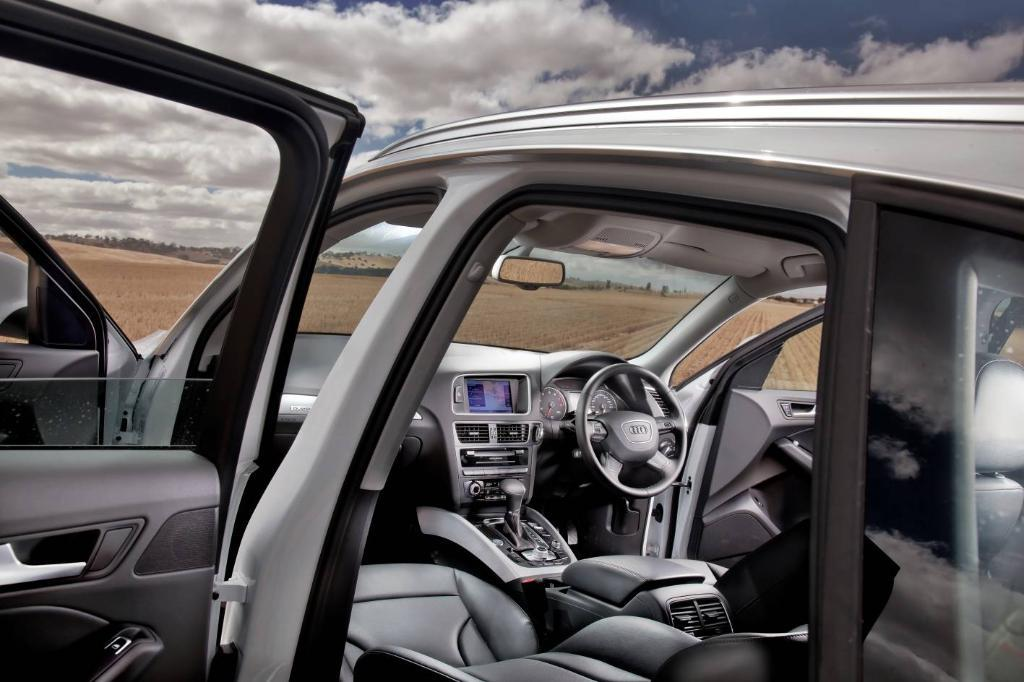What type of vehicle is in the image? The image contains a vehicle, but the specific type is not mentioned. What is located in front of the driver's seat in the vehicle? There is a steering wheel in the vehicle. What allows the driver to see the road ahead in the vehicle? There is a windshield in the vehicle. What helps the driver see behind the vehicle? There is a mirror in the vehicle. How does the driver change the speed of the vehicle? There is a gear in the vehicle. What device is present for entertainment in the vehicle? There is a music player in the vehicle. What is the weather like in the background of the image? The background of the image includes a cloudy sky. What type of mint is growing on the side of the vehicle in the image? There is no mint growing on the side of the vehicle in the image. 